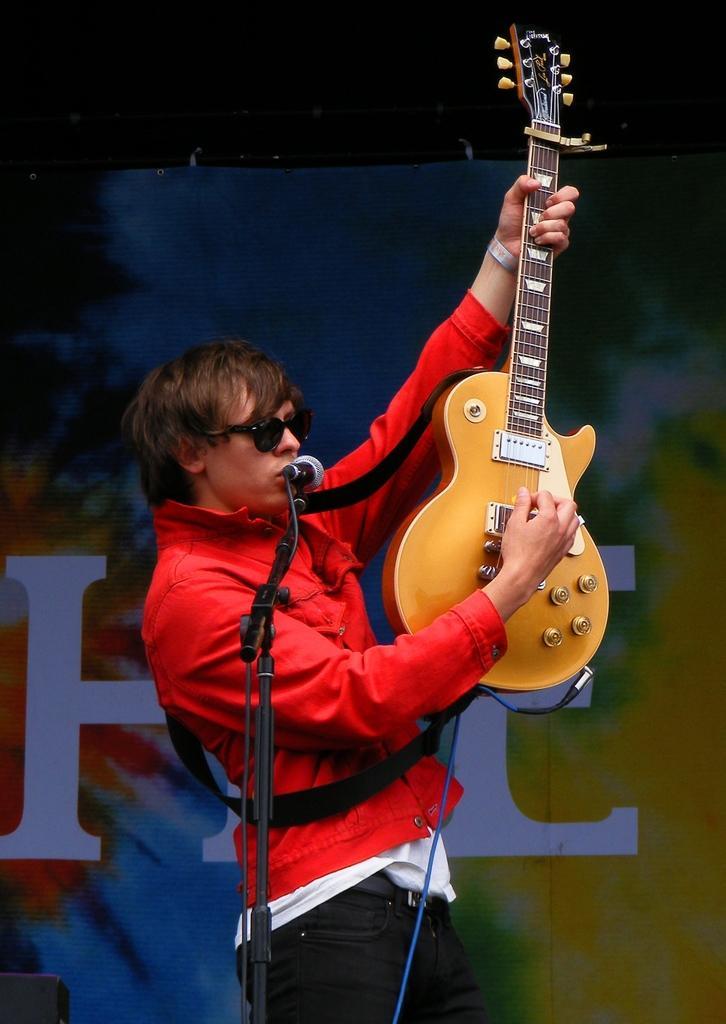Could you give a brief overview of what you see in this image? This image is taken outdoors. In the background there is a banner with a text on it. In the middle of the image there is a mic. A boy is standing and he is holding a guitar in his hands. 